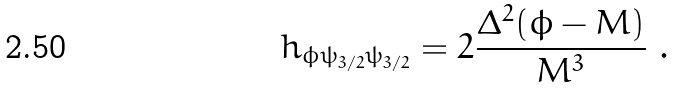<formula> <loc_0><loc_0><loc_500><loc_500>h _ { \phi \psi _ { 3 / 2 } \psi _ { 3 / 2 } } = 2 \frac { \Delta ^ { 2 } ( \phi - M ) } { M ^ { 3 } } \ .</formula> 